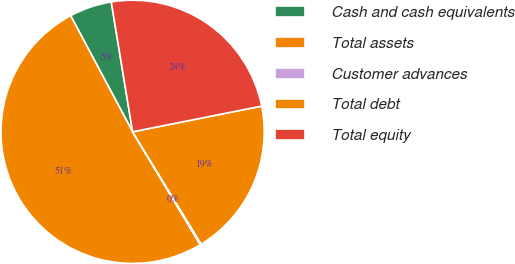<chart> <loc_0><loc_0><loc_500><loc_500><pie_chart><fcel>Cash and cash equivalents<fcel>Total assets<fcel>Customer advances<fcel>Total debt<fcel>Total equity<nl><fcel>5.21%<fcel>50.79%<fcel>0.14%<fcel>19.4%<fcel>24.46%<nl></chart> 